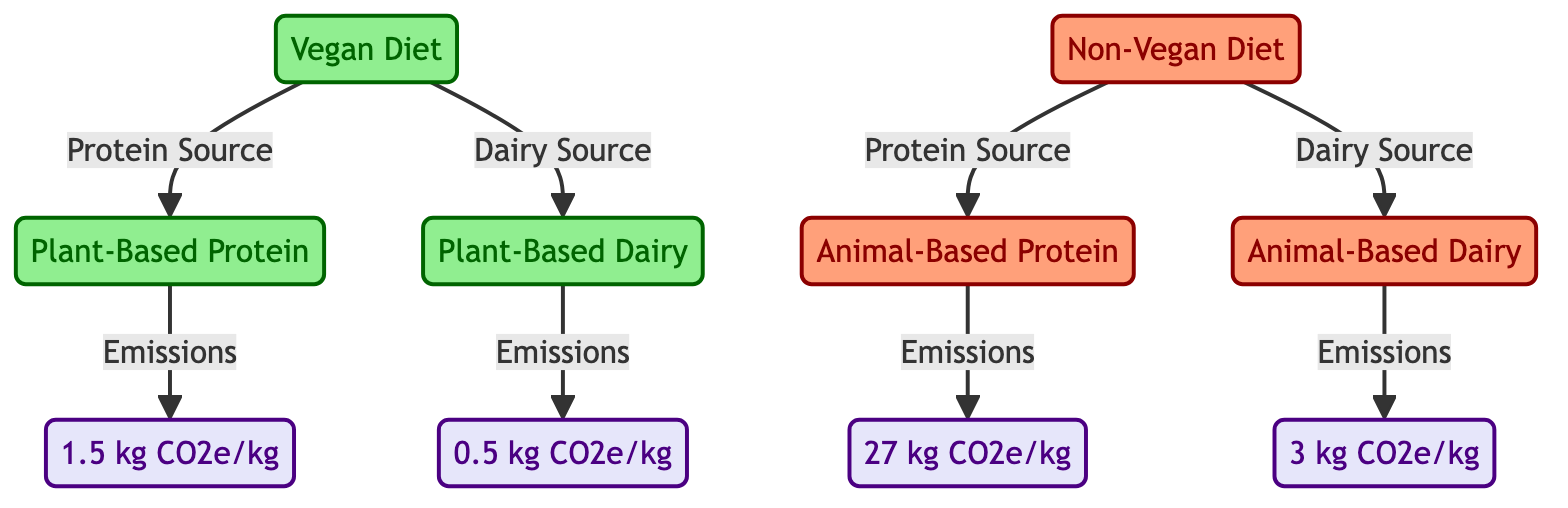What is the carbon footprint for plant-based protein? The diagram indicates that the carbon footprint for plant-based protein is shown as "1.5 kg CO2e/kg", which is connected directly from the vegan protein node to the emissions node.
Answer: 1.5 kg CO2e/kg What is the carbon footprint for animal-based dairy? According to the diagram, the emissions for animal-based dairy are labeled as "3 kg CO2e/kg" and are linked from the non-vegan dairy node to the emissions node.
Answer: 3 kg CO2e/kg Which diet has a lower protein source carbon footprint? The vegan protein node, with 1.5 kg CO2e/kg emissions, is lower than the non-vegan protein node, which has 27 kg CO2e/kg emissions. Therefore, the vegan diet has a lower carbon footprint for protein sources.
Answer: Vegan Diet What is the total number of nodes present in the diagram? The diagram consists of a total of 8 nodes, including 2 diet nodes, 2 protein source nodes, 2 dairy source nodes, and 4 emissions nodes. Adding them together results in 8 nodes.
Answer: 8 How much more carbon dioxide equivalent is emitted per kilogram from animal-based protein compared to plant-based protein? To calculate this, subtract the emissions of vegan protein (1.5 kg CO2e/kg) from non-vegan protein (27 kg CO2e/kg): 27 - 1.5 = 25.5 kg CO2e/kg more emissions. Therefore, animal-based protein emits 25.5 kg CO2e/kg more than plant-based protein.
Answer: 25.5 kg CO2e/kg What color represents the non-vegan diet in the diagram? The non-vegan diet is represented in the diagram by a salmon color, as indicated by the class definition of nonVegan in the diagram.
Answer: Salmon How do the emissions of plant-based dairy compare to those of animal-based dairy? The emissions for plant-based dairy (0.5 kg CO2e/kg) are significantly lower than those for animal-based dairy (3 kg CO2e/kg). This shows that plant-based dairy emits less CO2 equivalent compared to animal-based dairy.
Answer: Lower Which protein source has the highest emissions? The non-vegan protein source has the highest emissions, stated as "27 kg CO2e/kg" in the diagram, significantly higher than any other protein source.
Answer: Animal-Based Protein 